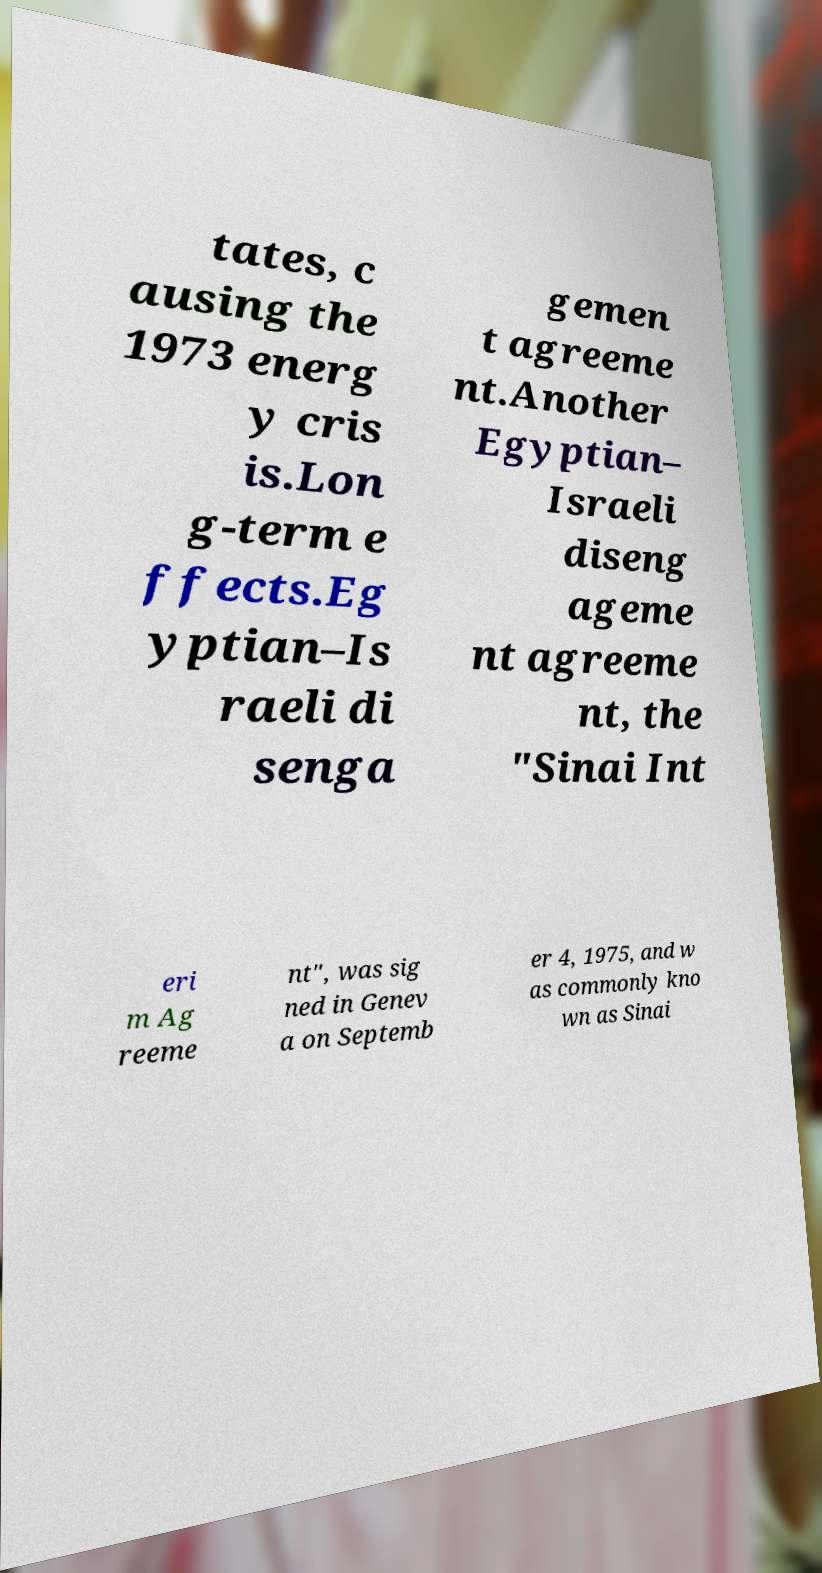For documentation purposes, I need the text within this image transcribed. Could you provide that? tates, c ausing the 1973 energ y cris is.Lon g-term e ffects.Eg yptian–Is raeli di senga gemen t agreeme nt.Another Egyptian– Israeli diseng ageme nt agreeme nt, the "Sinai Int eri m Ag reeme nt", was sig ned in Genev a on Septemb er 4, 1975, and w as commonly kno wn as Sinai 